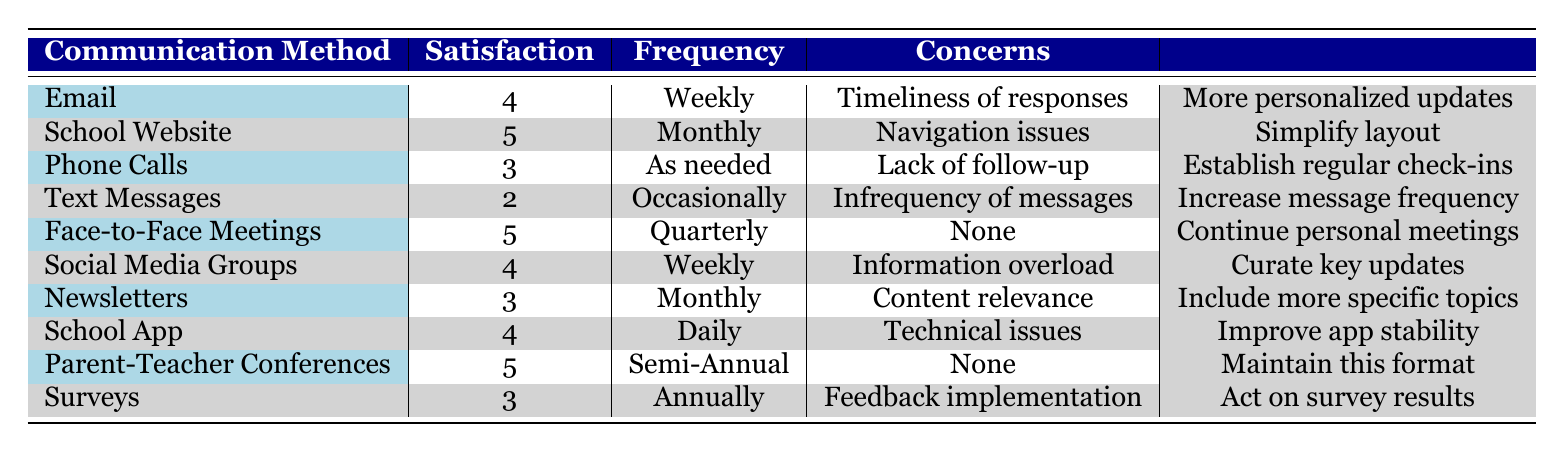What is the satisfaction rating of parents using the School Website for communication? The table shows that the satisfaction rating for the School Website is 5.
Answer: 5 How many different communication methods received a satisfaction rating of 4? The table lists the following communication methods with a rating of 4: Email, Social Media Groups, and School App. That totals three methods.
Answer: 3 Is there a communication method that has no concerns mentioned? In the table, both Face-to-Face Meetings and Parent-Teacher Conferences have "None" listed under concerns, indicating there are communication methods without concerns.
Answer: Yes What is the average satisfaction rating of all the listed communication methods? To calculate the average, we sum the satisfaction ratings: 4 + 5 + 3 + 2 + 5 + 4 + 3 + 4 + 5 + 3 = 43. There are 10 methods, so the average is 43/10 = 4.3.
Answer: 4.3 Which communication method had the lowest satisfaction rating, and what was that rating? The lowest satisfaction rating listed in the table is for Text Messages, with a rating of 2.
Answer: Text Messages, 2 How many communication methods were ranked with a satisfaction rating of 3? The table shows the following communication methods with a satisfaction rating of 3: Phone Calls, Newsletters, and Surveys. This sums to three methods.
Answer: 3 Are there any communication methods listed that are used less frequently than monthly? Yes, the Text Messages method is used occasionally, and the Phone Calls method is "As needed," which is less frequent than monthly.
Answer: Yes What is the total number of parents providing feedback on communication methods? Counting the entries in the table, there are 10 parents listed, meaning the total number of parents who provided feedback is 10.
Answer: 10 Which communication method has the highest satisfaction rating, and what recommendation is provided? The highest satisfaction rating in the table is 5, which is for Face-to-Face Meetings and Parent-Teacher Conferences. The recommendation for Face-to-Face Meetings is to "Continue personal meetings," while for Parent-Teacher Conferences, it's "Maintain this format."
Answer: Face-to-Face Meetings, Continue personal meetings 